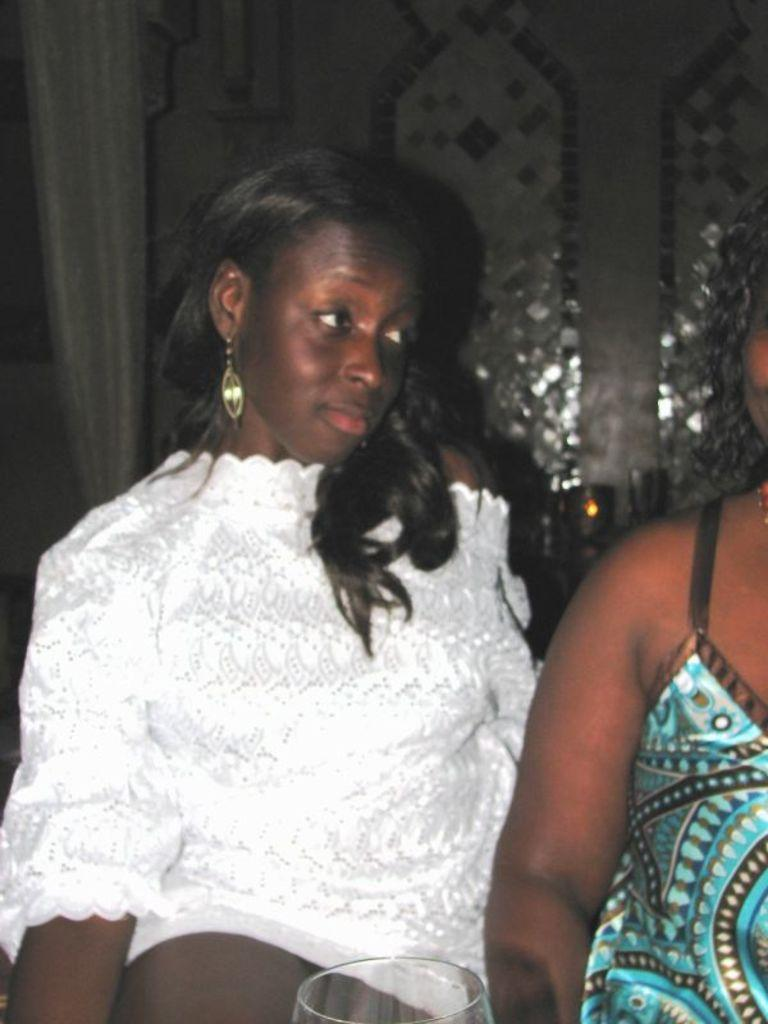How many people are in the image? There are two ladies in the image. What can be seen in the background of the image? There is a wall in the background of the image. What type of window treatment is present in the image? There is a white color curtain in the image. What material is visible at the bottom of the image? There is glass at the bottom of the image. What type of pets do the ladies have in the image? There are no pets visible in the image. 